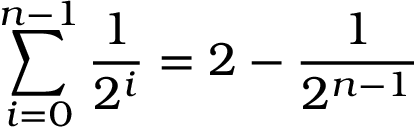<formula> <loc_0><loc_0><loc_500><loc_500>\sum _ { i = 0 } ^ { n - 1 } { \frac { 1 } { 2 ^ { i } } } = 2 - { \frac { 1 } { 2 ^ { n - 1 } } }</formula> 